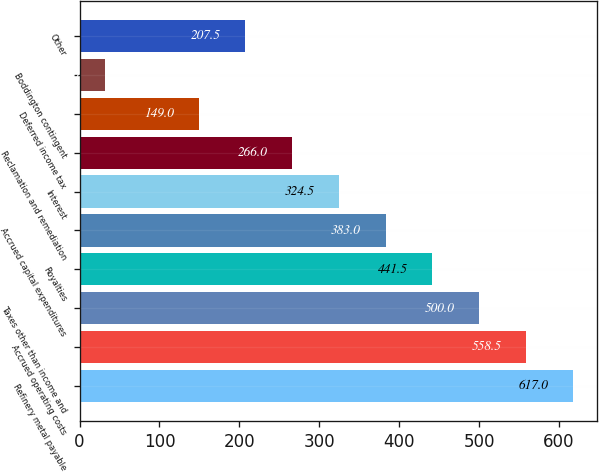Convert chart. <chart><loc_0><loc_0><loc_500><loc_500><bar_chart><fcel>Refinery metal payable<fcel>Accrued operating costs<fcel>Taxes other than income and<fcel>Royalties<fcel>Accrued capital expenditures<fcel>Interest<fcel>Reclamation and remediation<fcel>Deferred income tax<fcel>Boddington contingent<fcel>Other<nl><fcel>617<fcel>558.5<fcel>500<fcel>441.5<fcel>383<fcel>324.5<fcel>266<fcel>149<fcel>32<fcel>207.5<nl></chart> 